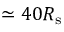<formula> <loc_0><loc_0><loc_500><loc_500>\simeq 4 0 R _ { s }</formula> 